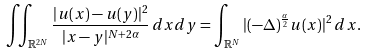Convert formula to latex. <formula><loc_0><loc_0><loc_500><loc_500>\iint _ { \mathbb { R } ^ { 2 N } } \frac { | u ( x ) - u ( y ) | ^ { 2 } } { | x - y | ^ { N + 2 \alpha } } \, d x d y = \int _ { \mathbb { R } ^ { N } } | ( - \Delta ) ^ { \frac { \alpha } { 2 } } u ( x ) | ^ { 2 } \, d x .</formula> 